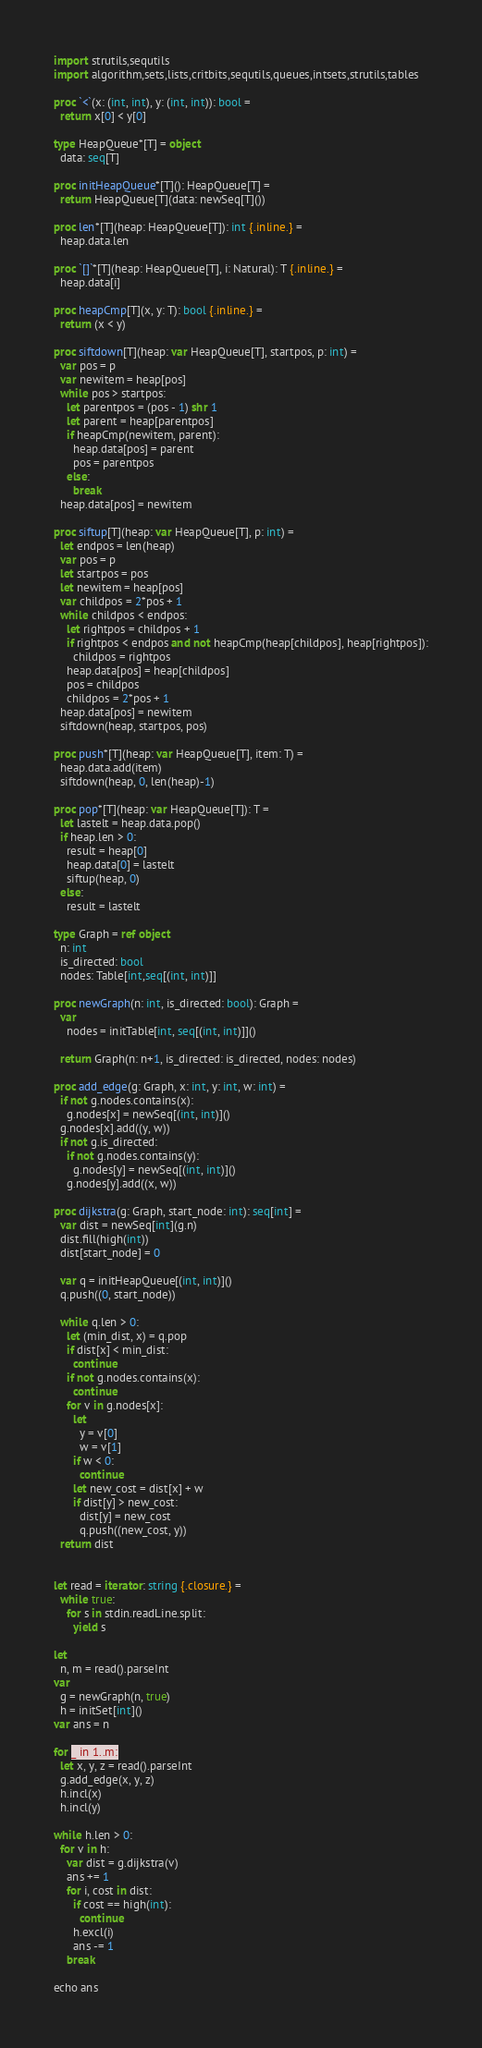<code> <loc_0><loc_0><loc_500><loc_500><_Nim_>import strutils,sequtils
import algorithm,sets,lists,critbits,sequtils,queues,intsets,strutils,tables

proc `<`(x: (int, int), y: (int, int)): bool =
  return x[0] < y[0]

type HeapQueue*[T] = object
  data: seq[T]

proc initHeapQueue*[T](): HeapQueue[T] =
  return HeapQueue[T](data: newSeq[T]())

proc len*[T](heap: HeapQueue[T]): int {.inline.} =
  heap.data.len

proc `[]`*[T](heap: HeapQueue[T], i: Natural): T {.inline.} =
  heap.data[i]

proc heapCmp[T](x, y: T): bool {.inline.} =
  return (x < y)

proc siftdown[T](heap: var HeapQueue[T], startpos, p: int) =
  var pos = p
  var newitem = heap[pos]
  while pos > startpos:
    let parentpos = (pos - 1) shr 1
    let parent = heap[parentpos]
    if heapCmp(newitem, parent):
      heap.data[pos] = parent
      pos = parentpos
    else:
      break
  heap.data[pos] = newitem

proc siftup[T](heap: var HeapQueue[T], p: int) =
  let endpos = len(heap)
  var pos = p
  let startpos = pos
  let newitem = heap[pos]
  var childpos = 2*pos + 1
  while childpos < endpos:
    let rightpos = childpos + 1
    if rightpos < endpos and not heapCmp(heap[childpos], heap[rightpos]):
      childpos = rightpos
    heap.data[pos] = heap[childpos]
    pos = childpos
    childpos = 2*pos + 1
  heap.data[pos] = newitem
  siftdown(heap, startpos, pos)

proc push*[T](heap: var HeapQueue[T], item: T) =
  heap.data.add(item)
  siftdown(heap, 0, len(heap)-1)

proc pop*[T](heap: var HeapQueue[T]): T =
  let lastelt = heap.data.pop()
  if heap.len > 0:
    result = heap[0]
    heap.data[0] = lastelt
    siftup(heap, 0)
  else:
    result = lastelt

type Graph = ref object
  n: int
  is_directed: bool
  nodes: Table[int,seq[(int, int)]]

proc newGraph(n: int, is_directed: bool): Graph =
  var
    nodes = initTable[int, seq[(int, int)]]()

  return Graph(n: n+1, is_directed: is_directed, nodes: nodes)

proc add_edge(g: Graph, x: int, y: int, w: int) =
  if not g.nodes.contains(x):
    g.nodes[x] = newSeq[(int, int)]()
  g.nodes[x].add((y, w))
  if not g.is_directed:
    if not g.nodes.contains(y):
      g.nodes[y] = newSeq[(int, int)]()
    g.nodes[y].add((x, w))

proc dijkstra(g: Graph, start_node: int): seq[int] =
  var dist = newSeq[int](g.n)
  dist.fill(high(int))
  dist[start_node] = 0

  var q = initHeapQueue[(int, int)]()
  q.push((0, start_node))

  while q.len > 0:
    let (min_dist, x) = q.pop
    if dist[x] < min_dist:
      continue
    if not g.nodes.contains(x):
      continue
    for v in g.nodes[x]:
      let
        y = v[0]
        w = v[1]
      if w < 0:
        continue
      let new_cost = dist[x] + w
      if dist[y] > new_cost:
        dist[y] = new_cost
        q.push((new_cost, y))
  return dist


let read = iterator: string {.closure.} =
  while true:
    for s in stdin.readLine.split:
      yield s

let
  n, m = read().parseInt
var
  g = newGraph(n, true)
  h = initSet[int]()
var ans = n

for _ in 1..m:
  let x, y, z = read().parseInt
  g.add_edge(x, y, z)
  h.incl(x)
  h.incl(y)

while h.len > 0:
  for v in h:
    var dist = g.dijkstra(v)
    ans += 1
    for i, cost in dist:
      if cost == high(int):
        continue
      h.excl(i)
      ans -= 1
    break

echo ans
</code> 